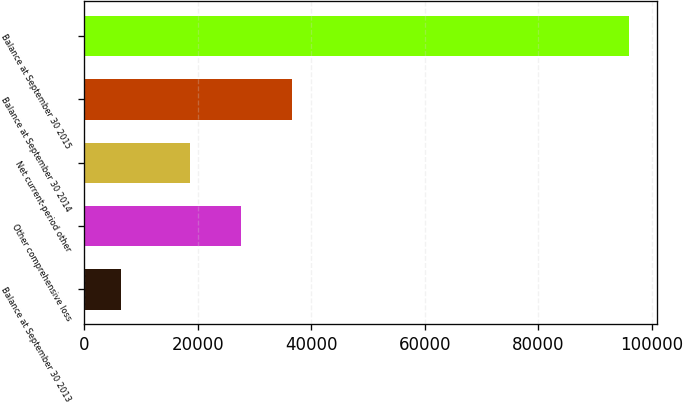Convert chart to OTSL. <chart><loc_0><loc_0><loc_500><loc_500><bar_chart><fcel>Balance at September 30 2013<fcel>Other comprehensive loss<fcel>Net current-period other<fcel>Balance at September 30 2014<fcel>Balance at September 30 2015<nl><fcel>6516<fcel>27604.3<fcel>18655<fcel>36553.6<fcel>96009<nl></chart> 